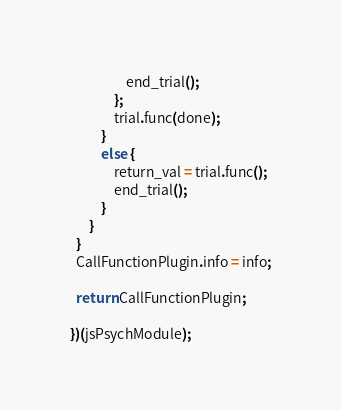<code> <loc_0><loc_0><loc_500><loc_500><_JavaScript_>                  end_trial();
              };
              trial.func(done);
          }
          else {
              return_val = trial.func();
              end_trial();
          }
      }
  }
  CallFunctionPlugin.info = info;

  return CallFunctionPlugin;

})(jsPsychModule);
</code> 